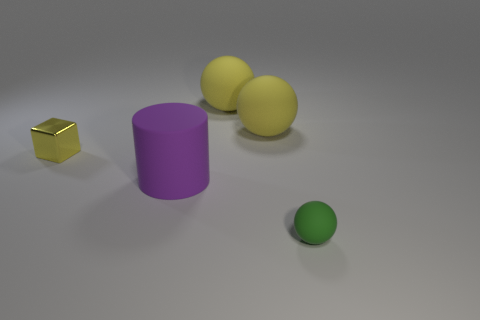What size is the matte sphere in front of the small object that is behind the big matte cylinder? Compared to the cylinder and the other objects in the scene, the matte sphere in front has a small size relative to its surroundings. It appears to be slightly larger in diameter than the small cube-like object behind it. 